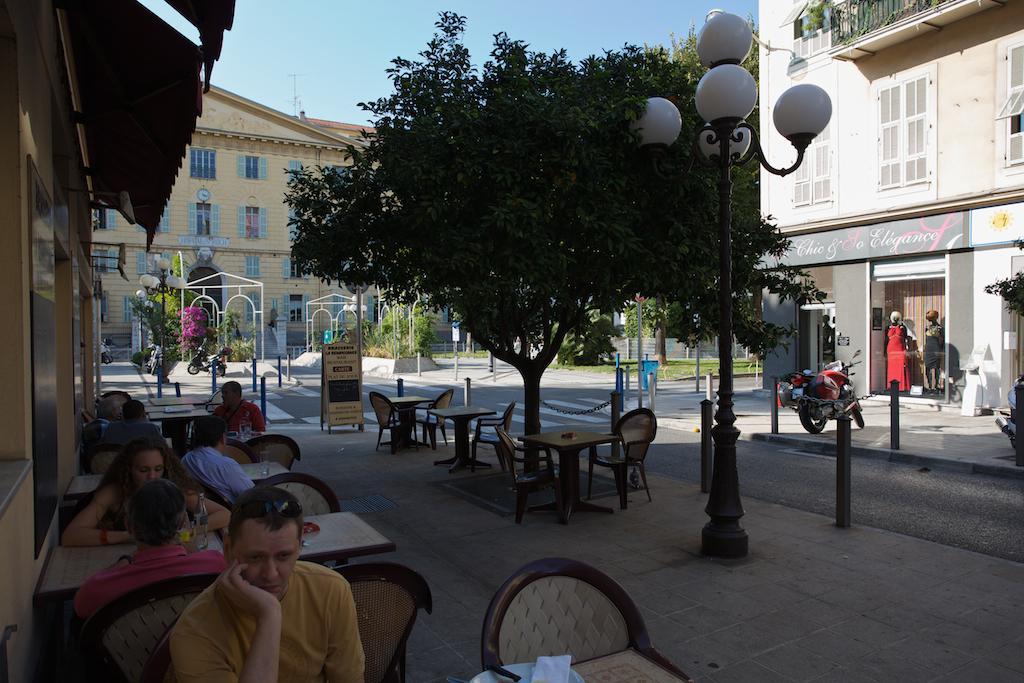Describe this image in one or two sentences. In this image I can see few people who are sitting on chairs and I see number of tables and many more chairs and I see a pole on which there are 5 white color bulbs. On the right side of this image I see a bike. In the middle of this picture I can see the buildings, few trees and few poles. In the background I can see the sky. 